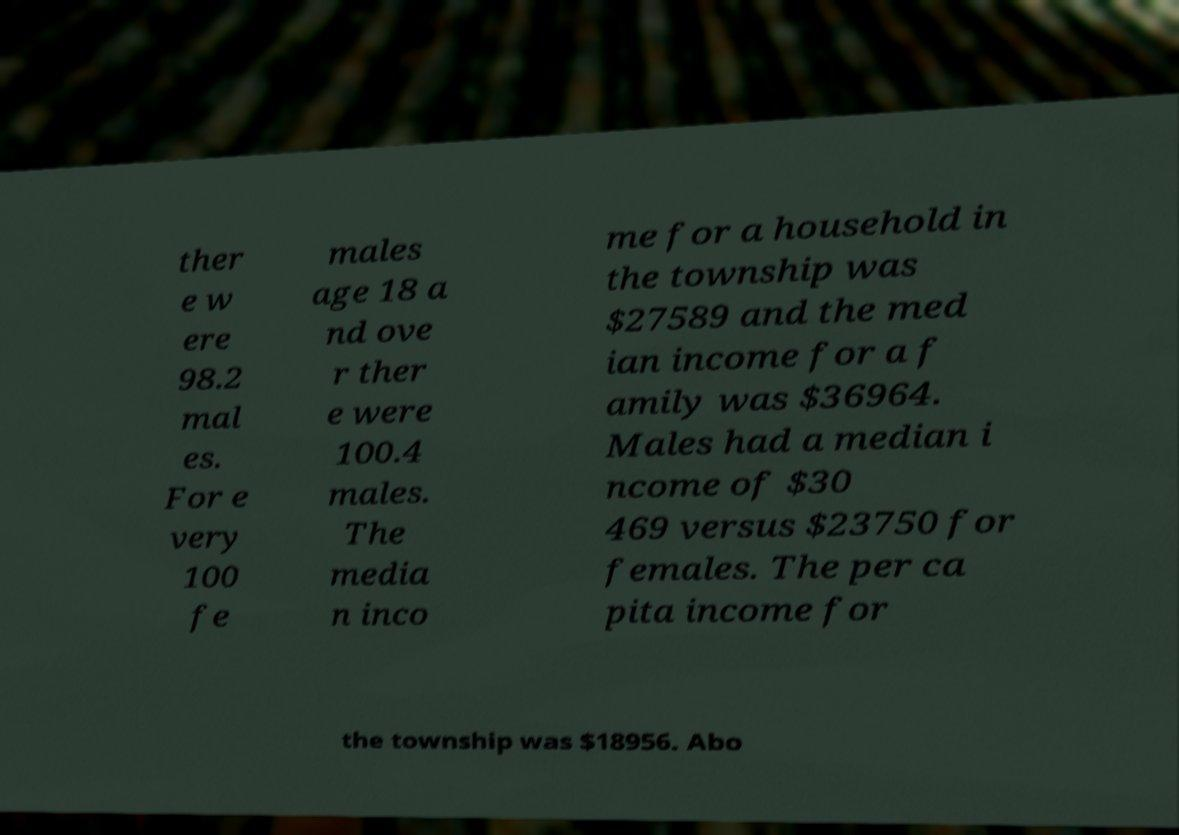What messages or text are displayed in this image? I need them in a readable, typed format. ther e w ere 98.2 mal es. For e very 100 fe males age 18 a nd ove r ther e were 100.4 males. The media n inco me for a household in the township was $27589 and the med ian income for a f amily was $36964. Males had a median i ncome of $30 469 versus $23750 for females. The per ca pita income for the township was $18956. Abo 